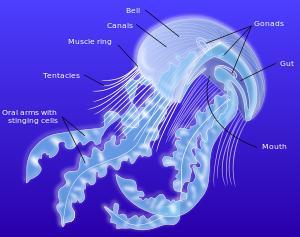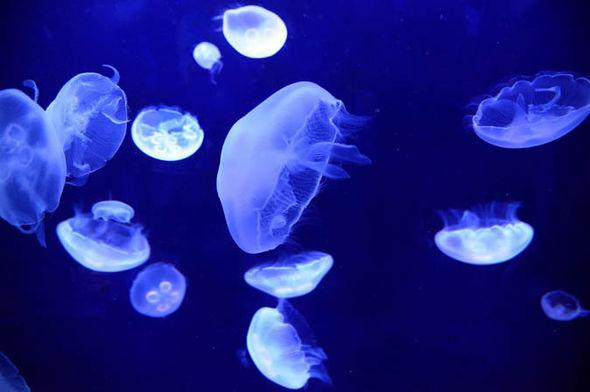The first image is the image on the left, the second image is the image on the right. Analyze the images presented: Is the assertion "There is a red jellyfish on one of the iamges." valid? Answer yes or no. No. 